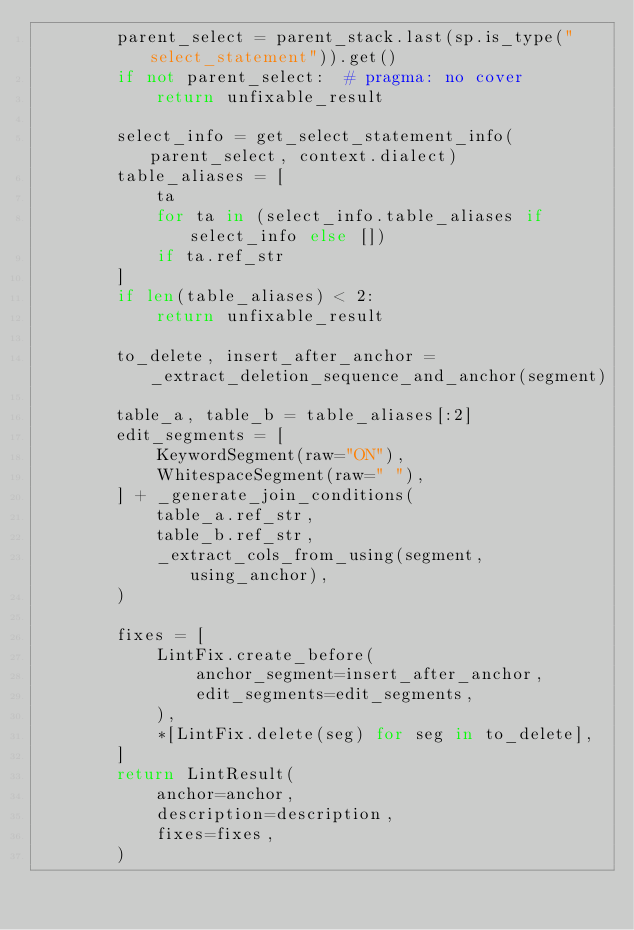Convert code to text. <code><loc_0><loc_0><loc_500><loc_500><_Python_>        parent_select = parent_stack.last(sp.is_type("select_statement")).get()
        if not parent_select:  # pragma: no cover
            return unfixable_result

        select_info = get_select_statement_info(parent_select, context.dialect)
        table_aliases = [
            ta
            for ta in (select_info.table_aliases if select_info else [])
            if ta.ref_str
        ]
        if len(table_aliases) < 2:
            return unfixable_result

        to_delete, insert_after_anchor = _extract_deletion_sequence_and_anchor(segment)

        table_a, table_b = table_aliases[:2]
        edit_segments = [
            KeywordSegment(raw="ON"),
            WhitespaceSegment(raw=" "),
        ] + _generate_join_conditions(
            table_a.ref_str,
            table_b.ref_str,
            _extract_cols_from_using(segment, using_anchor),
        )

        fixes = [
            LintFix.create_before(
                anchor_segment=insert_after_anchor,
                edit_segments=edit_segments,
            ),
            *[LintFix.delete(seg) for seg in to_delete],
        ]
        return LintResult(
            anchor=anchor,
            description=description,
            fixes=fixes,
        )

</code> 